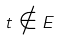Convert formula to latex. <formula><loc_0><loc_0><loc_500><loc_500>t \notin E</formula> 